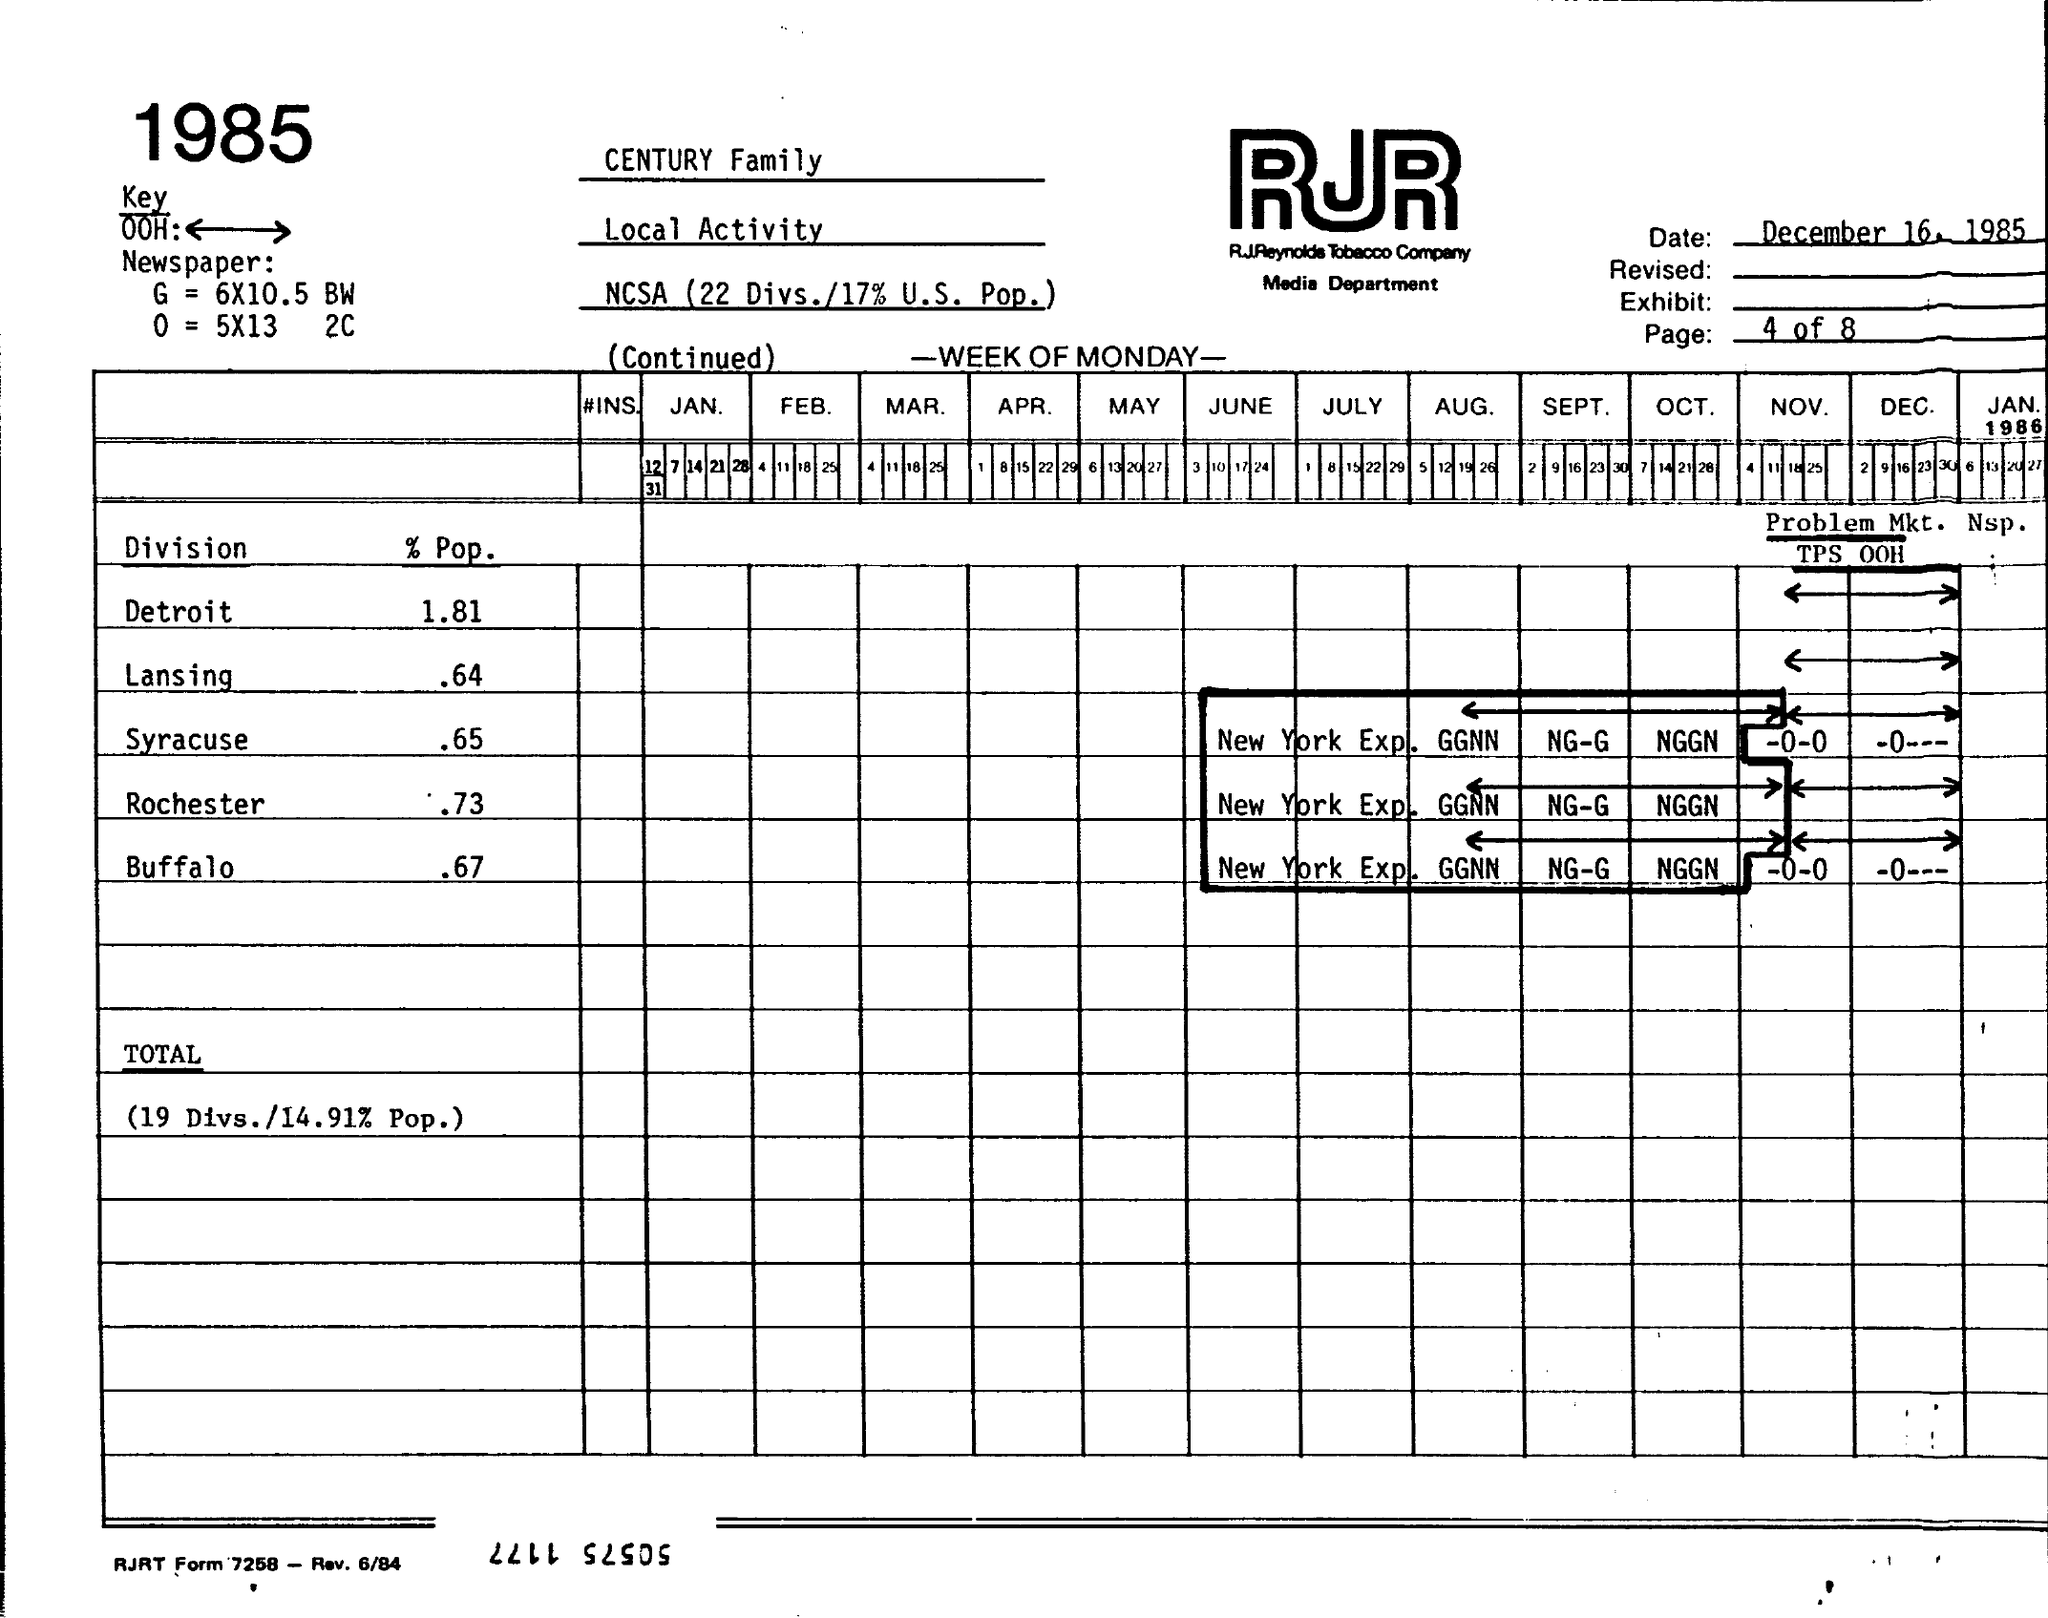Point out several critical features in this image. The date is December 16, 1985. The percentage of population for Syracuse is 65%. The percentage of the population of Rochester is 0.73. The population of Buffalo is estimated to be approximately 67%. The percent population for Detroit is 1.81%. 